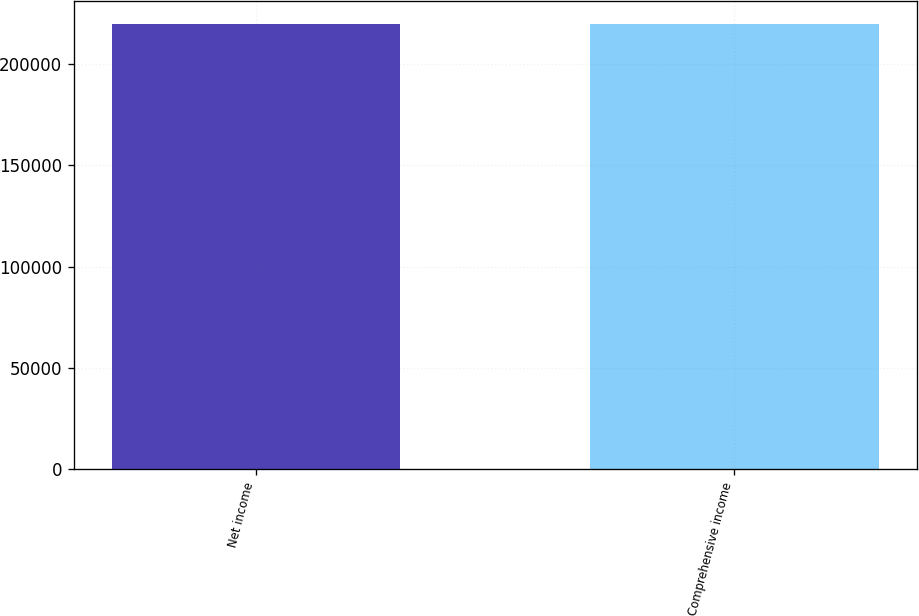Convert chart to OTSL. <chart><loc_0><loc_0><loc_500><loc_500><bar_chart><fcel>Net income<fcel>Comprehensive income<nl><fcel>219952<fcel>219804<nl></chart> 